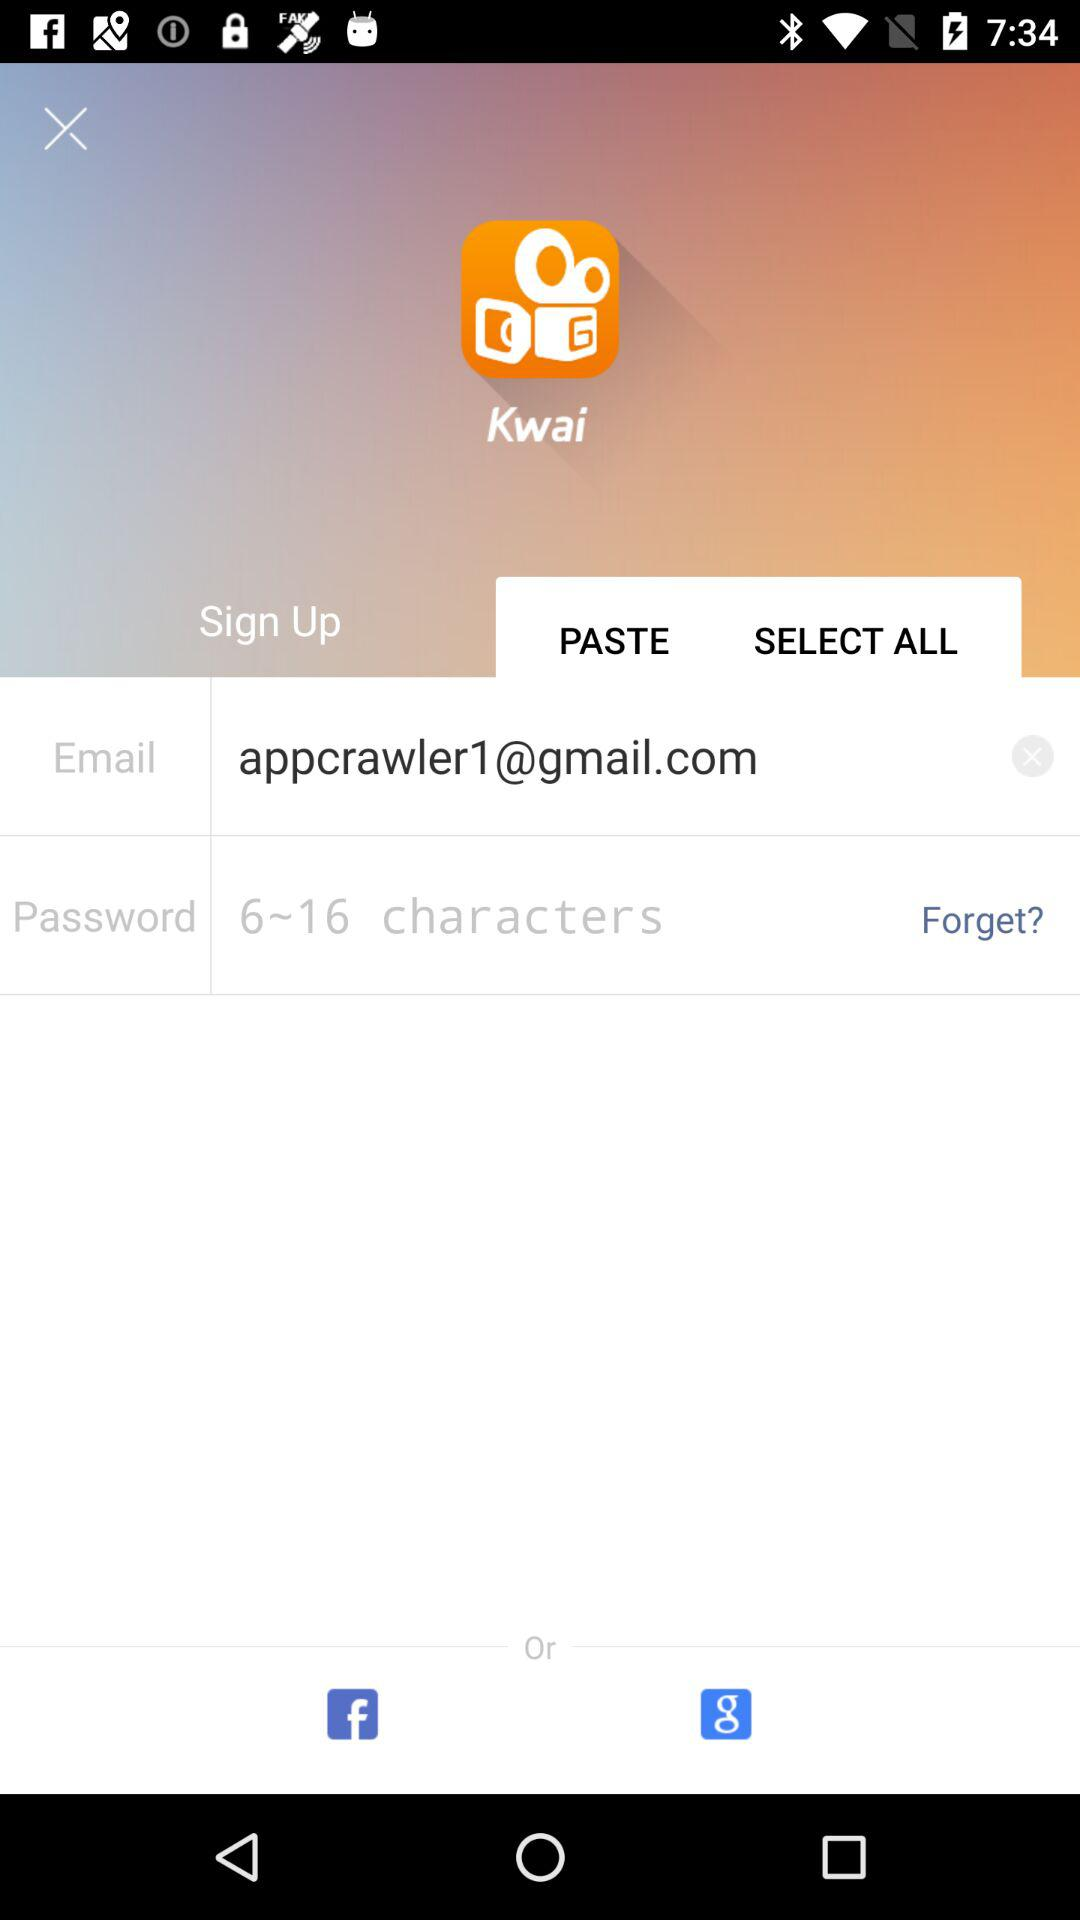What is the email address? The email address is appcrawler1@gmail.com. 